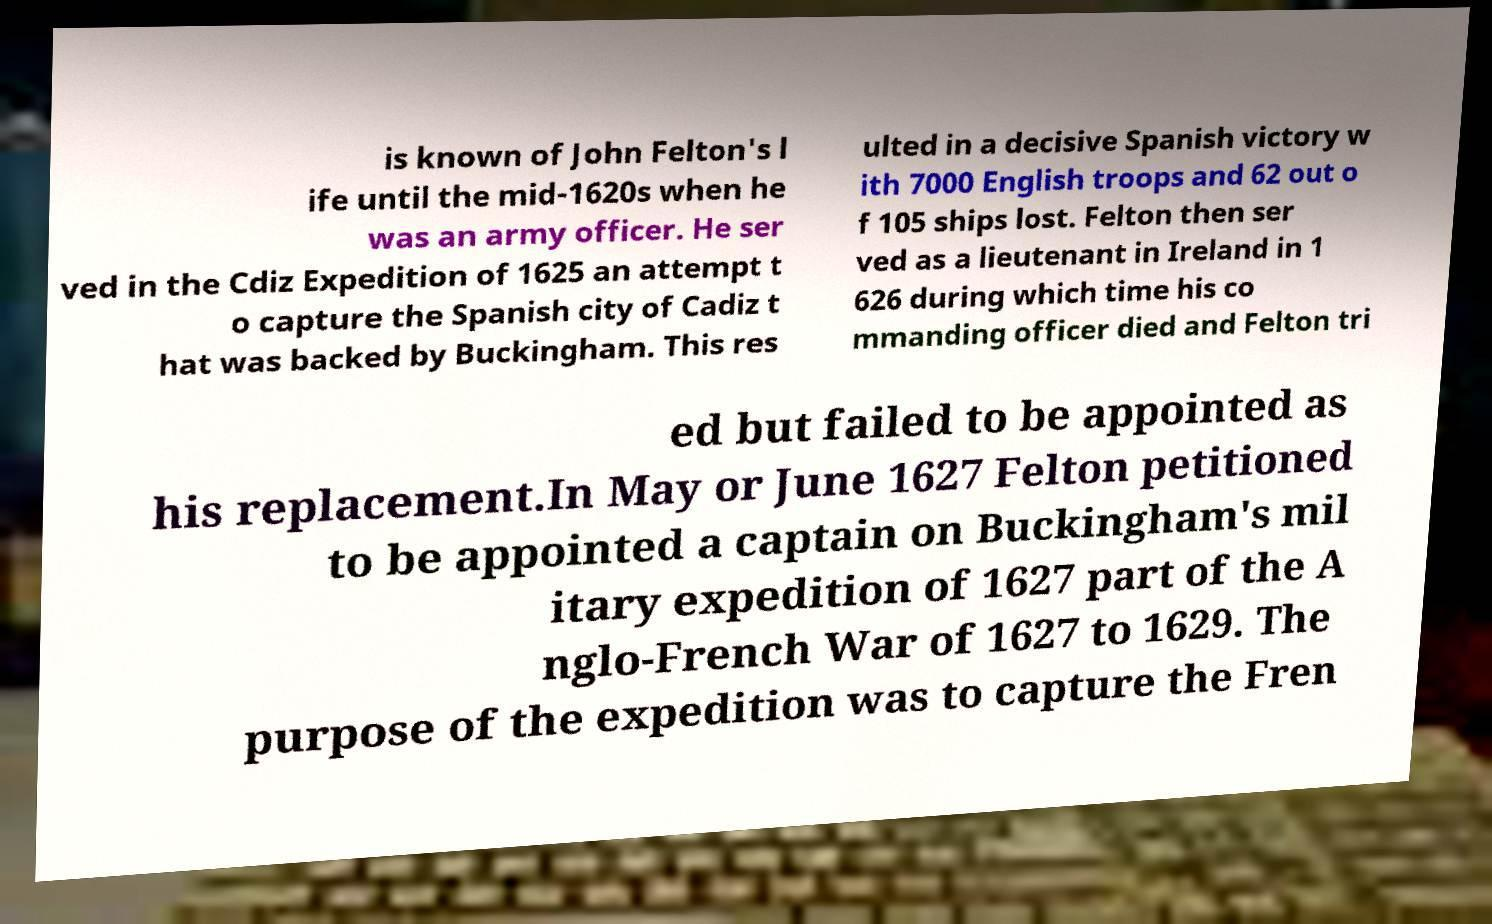Could you assist in decoding the text presented in this image and type it out clearly? is known of John Felton's l ife until the mid-1620s when he was an army officer. He ser ved in the Cdiz Expedition of 1625 an attempt t o capture the Spanish city of Cadiz t hat was backed by Buckingham. This res ulted in a decisive Spanish victory w ith 7000 English troops and 62 out o f 105 ships lost. Felton then ser ved as a lieutenant in Ireland in 1 626 during which time his co mmanding officer died and Felton tri ed but failed to be appointed as his replacement.In May or June 1627 Felton petitioned to be appointed a captain on Buckingham's mil itary expedition of 1627 part of the A nglo-French War of 1627 to 1629. The purpose of the expedition was to capture the Fren 